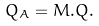Convert formula to latex. <formula><loc_0><loc_0><loc_500><loc_500>Q _ { A } = M . Q .</formula> 